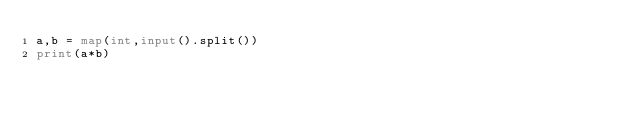Convert code to text. <code><loc_0><loc_0><loc_500><loc_500><_Python_>a,b = map(int,input().split())
print(a*b)</code> 